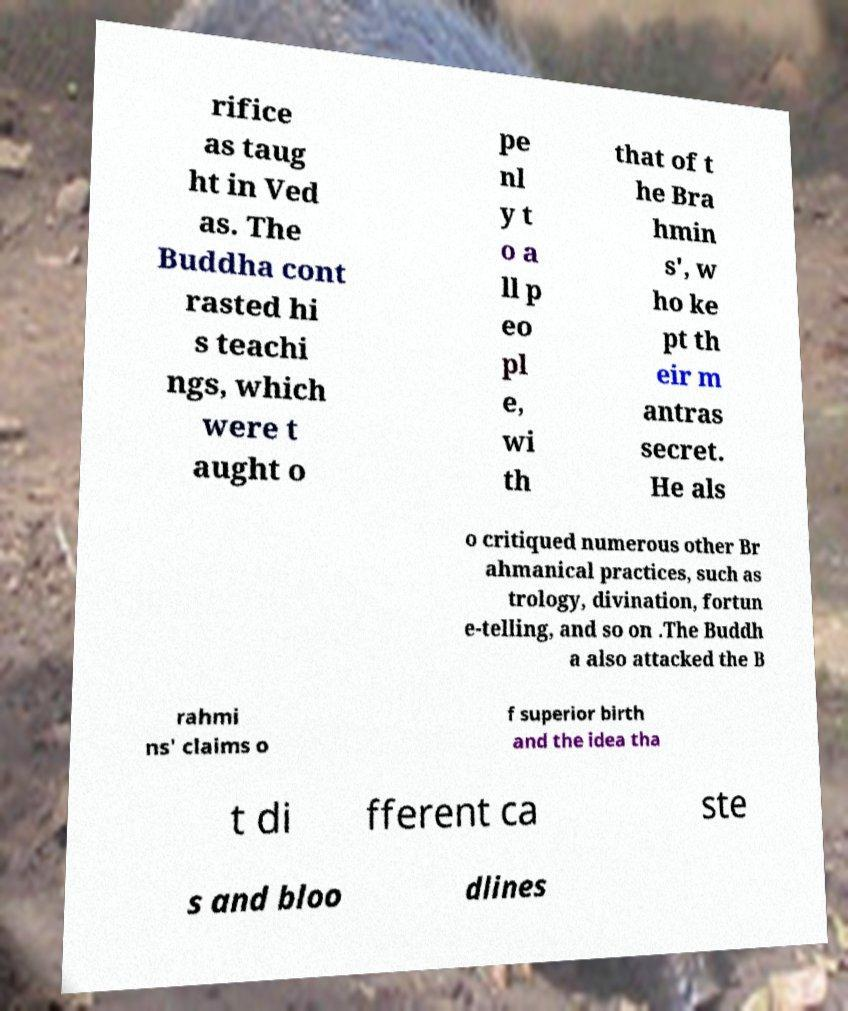Please read and relay the text visible in this image. What does it say? rifice as taug ht in Ved as. The Buddha cont rasted hi s teachi ngs, which were t aught o pe nl y t o a ll p eo pl e, wi th that of t he Bra hmin s', w ho ke pt th eir m antras secret. He als o critiqued numerous other Br ahmanical practices, such as trology, divination, fortun e-telling, and so on .The Buddh a also attacked the B rahmi ns' claims o f superior birth and the idea tha t di fferent ca ste s and bloo dlines 